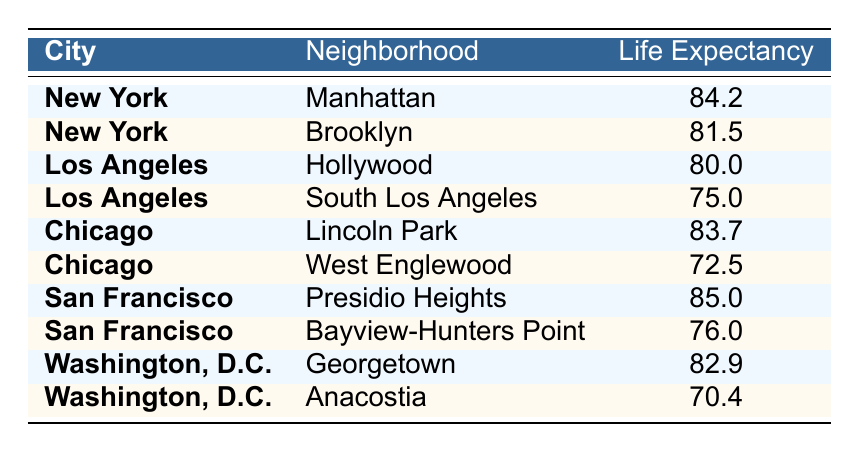What is the life expectancy in Manhattan? The table shows the life expectancy for each neighborhood. In the row for New York under the neighborhood Manhattan, the life expectancy is listed as 84.2 years.
Answer: 84.2 Which neighborhood in Los Angeles has the lowest life expectancy? The table lists two neighborhoods in Los Angeles: Hollywood and South Los Angeles. Hollywood has a life expectancy of 80.0 and South Los Angeles has 75.0. Since 75.0 is lower, South Los Angeles has the lowest life expectancy.
Answer: South Los Angeles What is the average life expectancy of neighborhoods in Chicago? In Chicago, the neighborhoods listed are Lincoln Park with a life expectancy of 83.7 and West Englewood with 72.5. To find the average, sum these values: 83.7 + 72.5 = 156.2. Now divide by the number of neighborhoods (2): 156.2 / 2 = 78.1.
Answer: 78.1 Is the life expectancy in Georgetown higher than that in Brooklyn? The life expectancy in Georgetown is 82.9 years, and in Brooklyn, it is 81.5 years. Since 82.9 is greater than 81.5, this statement is true.
Answer: Yes What is the difference in life expectancy between the highest and lowest neighborhoods across the table? The highest life expectancy is found in Presidio Heights (85.0 years), and the lowest is in Anacostia (70.4 years). To find the difference: 85.0 - 70.4 = 14.6 years.
Answer: 14.6 